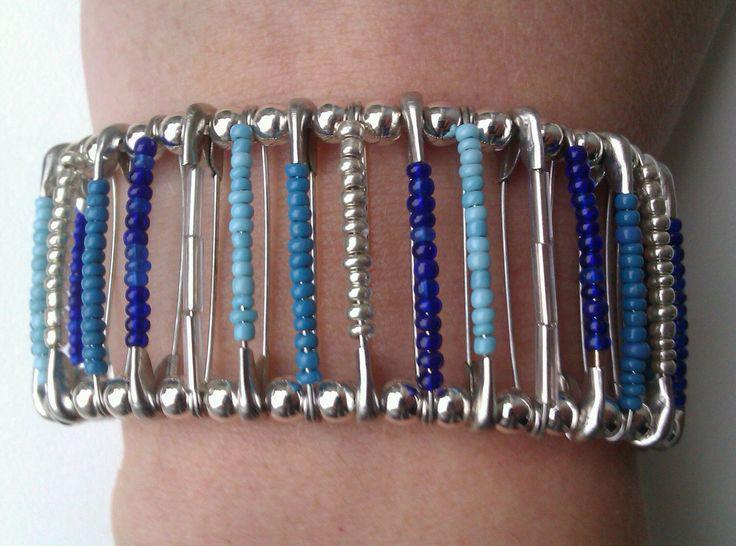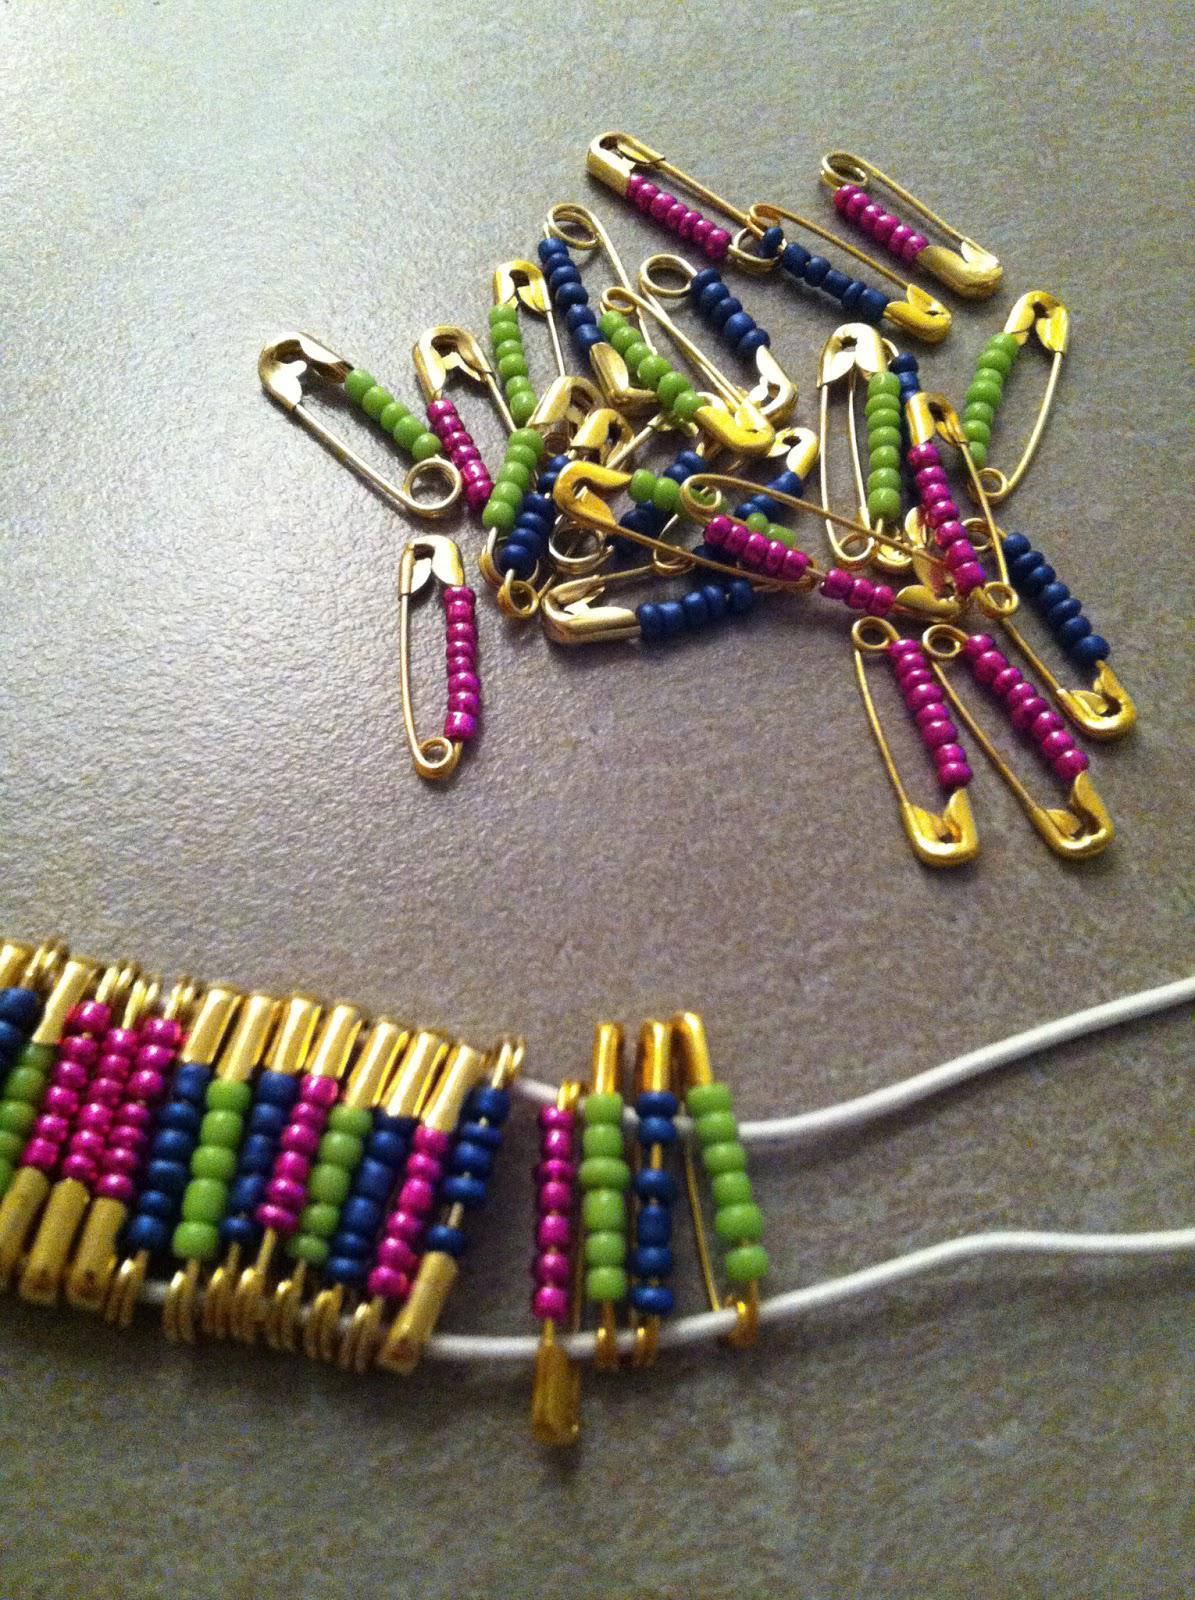The first image is the image on the left, the second image is the image on the right. Assess this claim about the two images: "In one image, a bracelet made out of safety pins and blue and silver beads is on the arm of a person.". Correct or not? Answer yes or no. Yes. The first image is the image on the left, the second image is the image on the right. Considering the images on both sides, is "A bracelet is worn by a person." valid? Answer yes or no. Yes. 